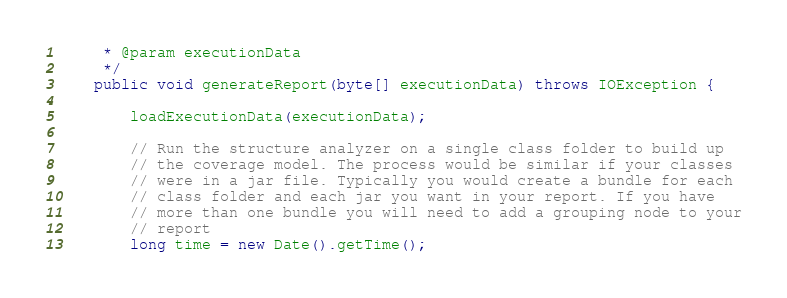Convert code to text. <code><loc_0><loc_0><loc_500><loc_500><_Java_>     * @param executionData
     */
    public void generateReport(byte[] executionData) throws IOException {

        loadExecutionData(executionData);

        // Run the structure analyzer on a single class folder to build up
        // the coverage model. The process would be similar if your classes
        // were in a jar file. Typically you would create a bundle for each
        // class folder and each jar you want in your report. If you have
        // more than one bundle you will need to add a grouping node to your
        // report
        long time = new Date().getTime();
</code> 